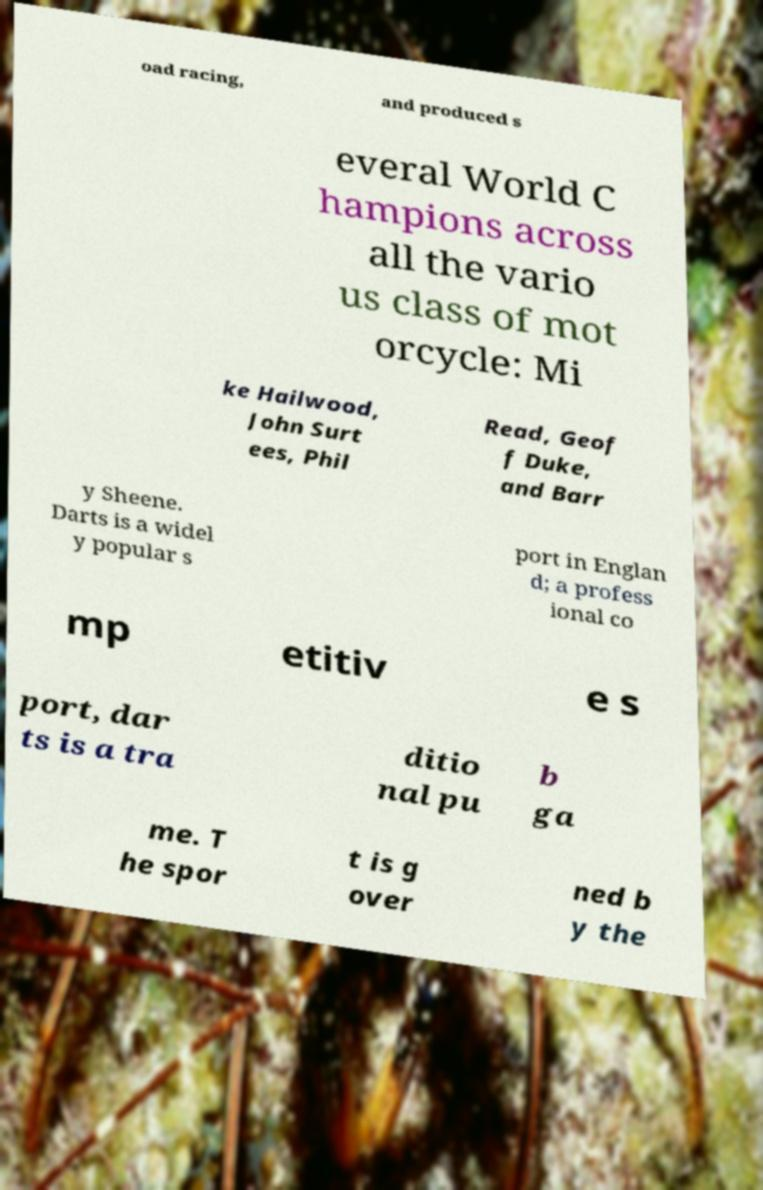Could you assist in decoding the text presented in this image and type it out clearly? oad racing, and produced s everal World C hampions across all the vario us class of mot orcycle: Mi ke Hailwood, John Surt ees, Phil Read, Geof f Duke, and Barr y Sheene. Darts is a widel y popular s port in Englan d; a profess ional co mp etitiv e s port, dar ts is a tra ditio nal pu b ga me. T he spor t is g over ned b y the 